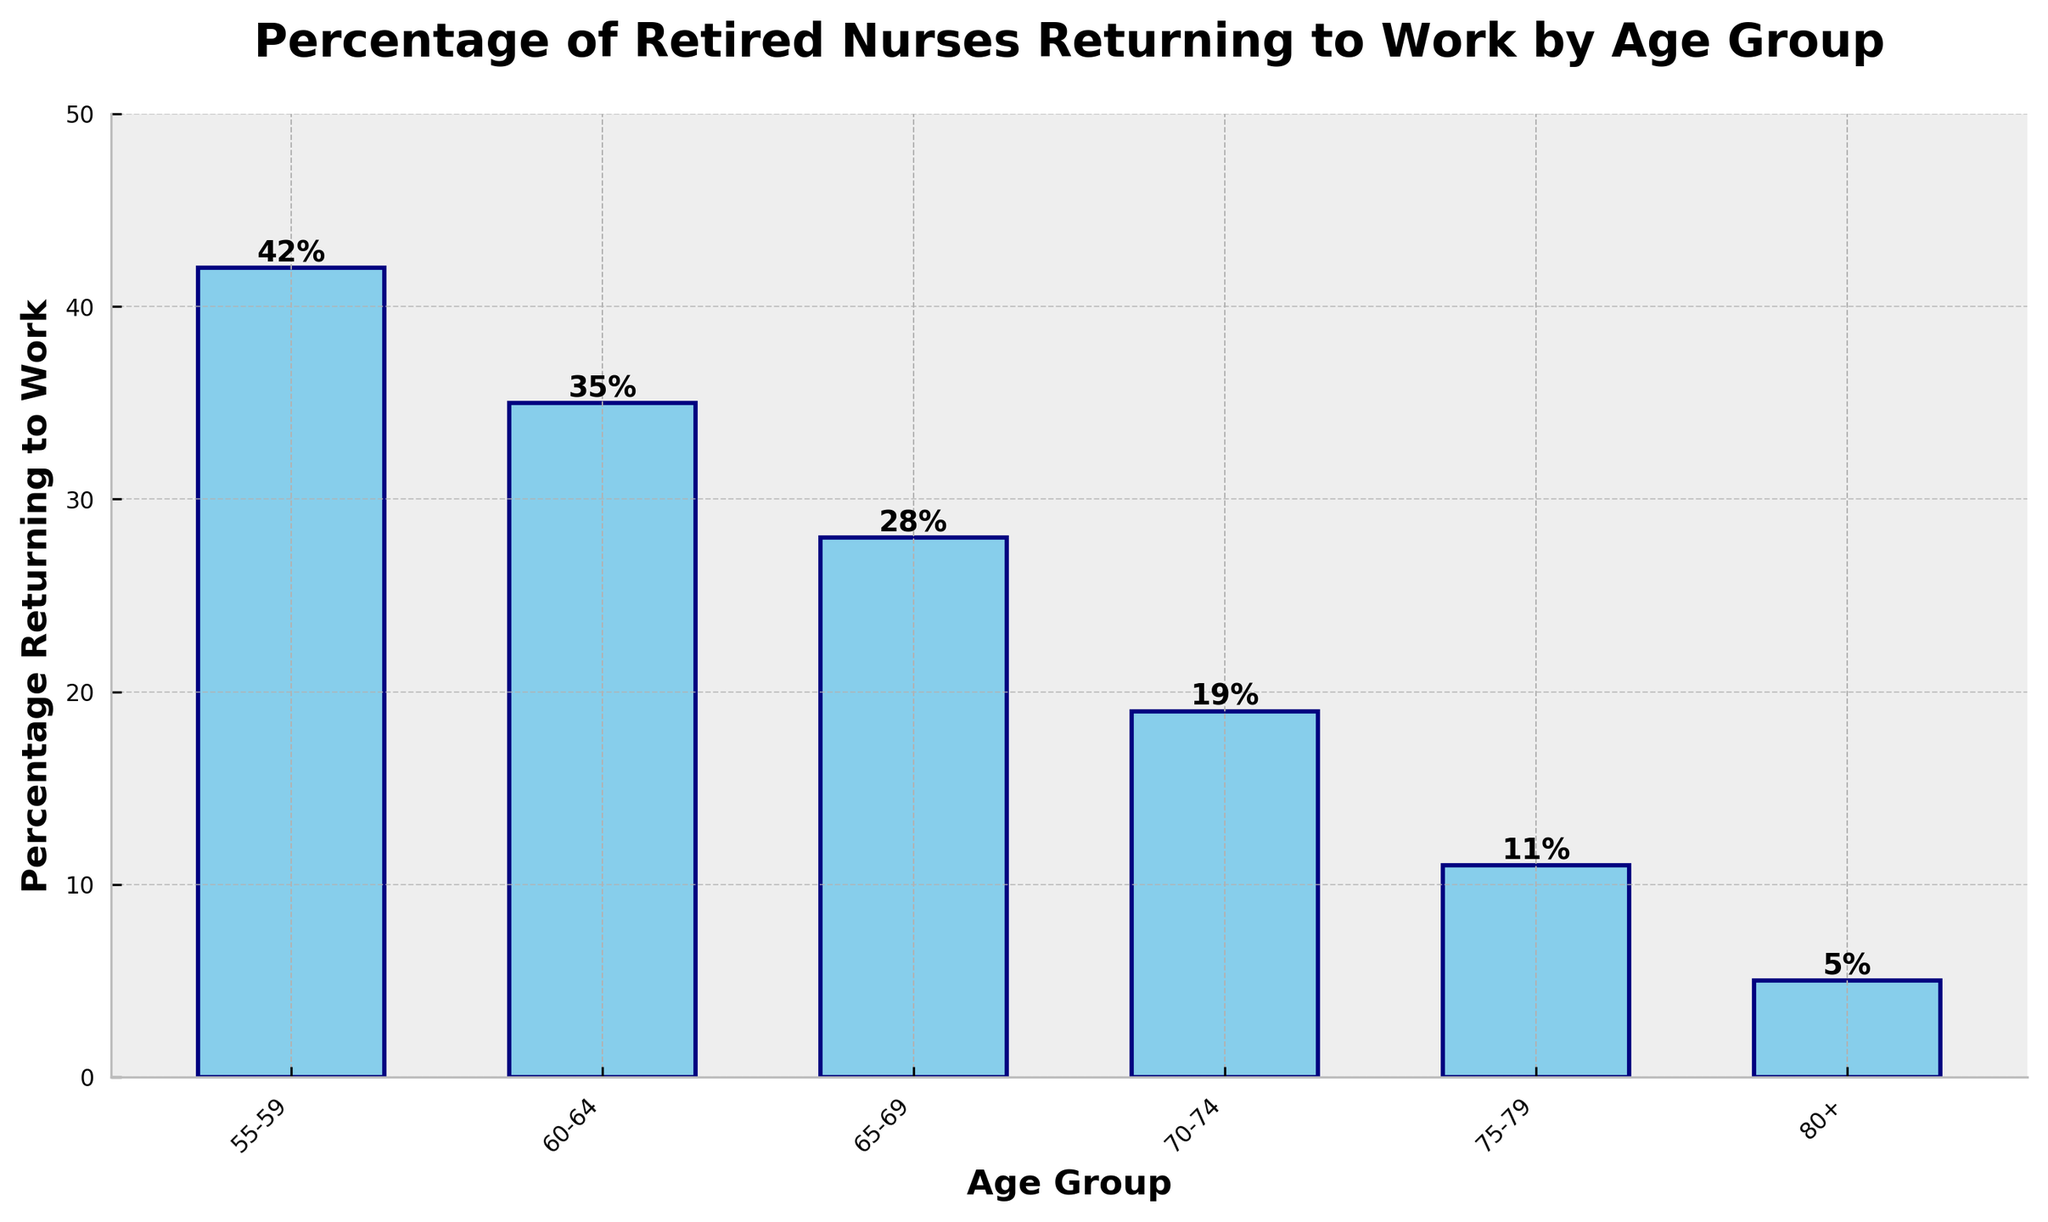what is the percentage of retired nurses returning to work in the 60-64 age group? The bar corresponding to the 60-64 age group on the graph shows a height of 35%.
Answer: 35% In which age group is the percentage of retired nurses returning to work the highest? By examining the bar heights, the 55-59 age group shows the tallest bar indicating the highest percentage of returning nurses.
Answer: 55-59 What is the difference in the percentage of retired nurses returning to work between the 55-59 and 65-69 age groups? The bar for the 55-59 age group indicates 42%, and the bar for the 65-69 age group indicates 28%. The difference is 42% - 28%.
Answer: 14% Across which age groups is there a noticeable decline in the percentage of nurses returning to work from 55-59 to 60-64? From the graph, the bar for the 55-59 age group is at 42% while the bar for the 60-64 age group is at 35%. The percentage thus declines from 42% to 35%, showing a noticeable decrease.
Answer: 55-59 to 60-64 What is the sum of the percentages of retired nurses returning to work in the 55-59 and 70-74 age groups? The bar for the 55-59 age group indicates 42%, and for the 70-74 age group, it indicates 19%. Summing these percentages gives 42% + 19%.
Answer: 61% Which age group experiences the smallest percentage of retired nurses returning to work? The bar corresponding to the 80+ age group is the shortest, showing the smallest percentage at 5%.
Answer: 80+ Between which two consecutive age groups is the largest drop in the percentage of retired nurses returning to work observed? The percentage drops can be calculated as follows: 55-59 to 60-64 (42% to 35%, drop of 7%), 60-64 to 65-69 (35% to 28%, drop of 7%), 65-69 to 70-74 (28% to 19%, drop of 9%), 70-74 to 75-79 (19% to 11%, drop of 8%), and 75-79 to 80+ (11% to 5%, drop of 6%). The largest drop is from 65-69 to 70-74 (9%).
Answer: 65-69 to 70-74 